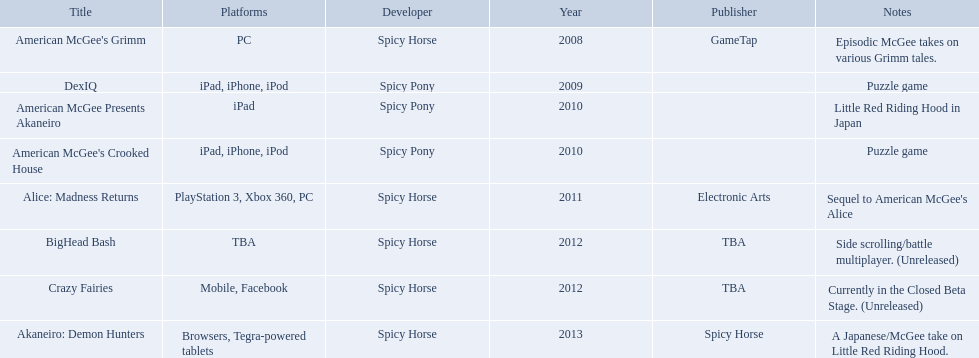What spicy horse titles are listed? American McGee's Grimm, DexIQ, American McGee Presents Akaneiro, American McGee's Crooked House, Alice: Madness Returns, BigHead Bash, Crazy Fairies, Akaneiro: Demon Hunters. Which of these can be used on ipad? DexIQ, American McGee Presents Akaneiro, American McGee's Crooked House. Which left cannot also be used on iphone or ipod? American McGee Presents Akaneiro. 